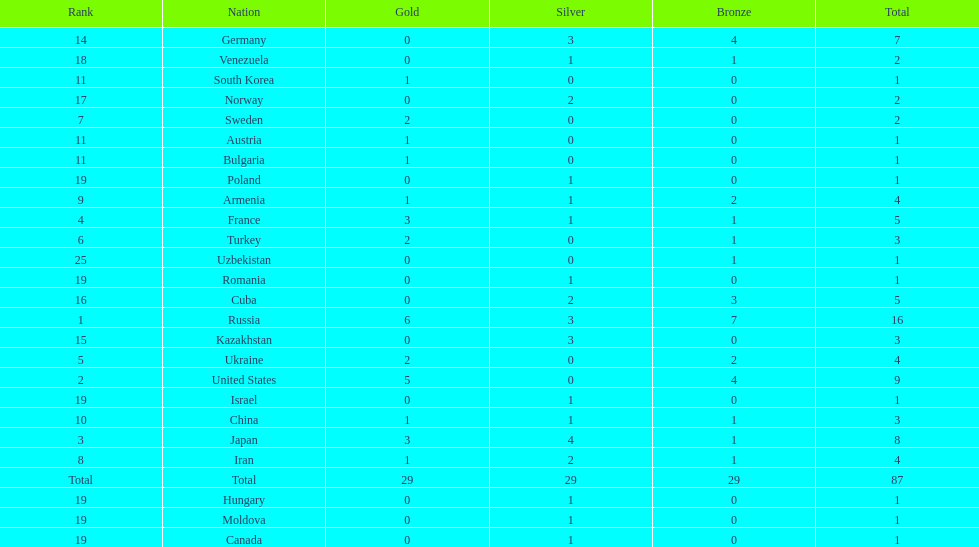Which nation has one gold medal but zero in both silver and bronze? Austria. 